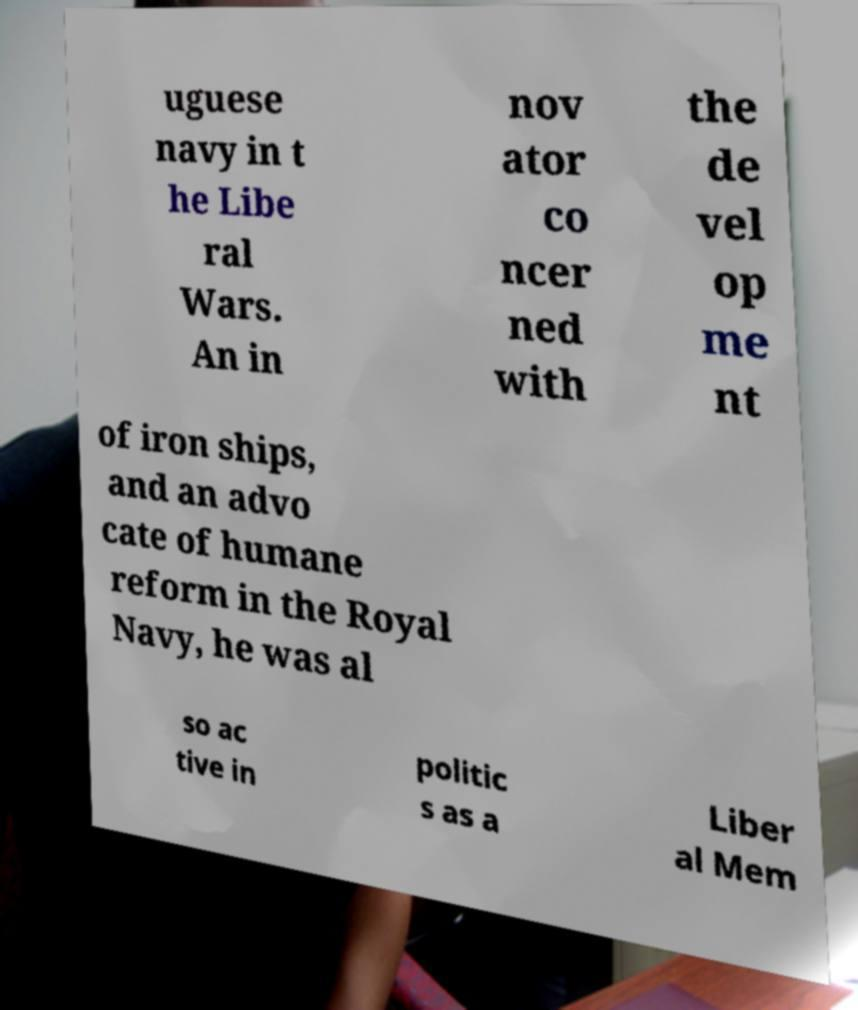Can you accurately transcribe the text from the provided image for me? uguese navy in t he Libe ral Wars. An in nov ator co ncer ned with the de vel op me nt of iron ships, and an advo cate of humane reform in the Royal Navy, he was al so ac tive in politic s as a Liber al Mem 